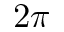Convert formula to latex. <formula><loc_0><loc_0><loc_500><loc_500>2 \pi</formula> 